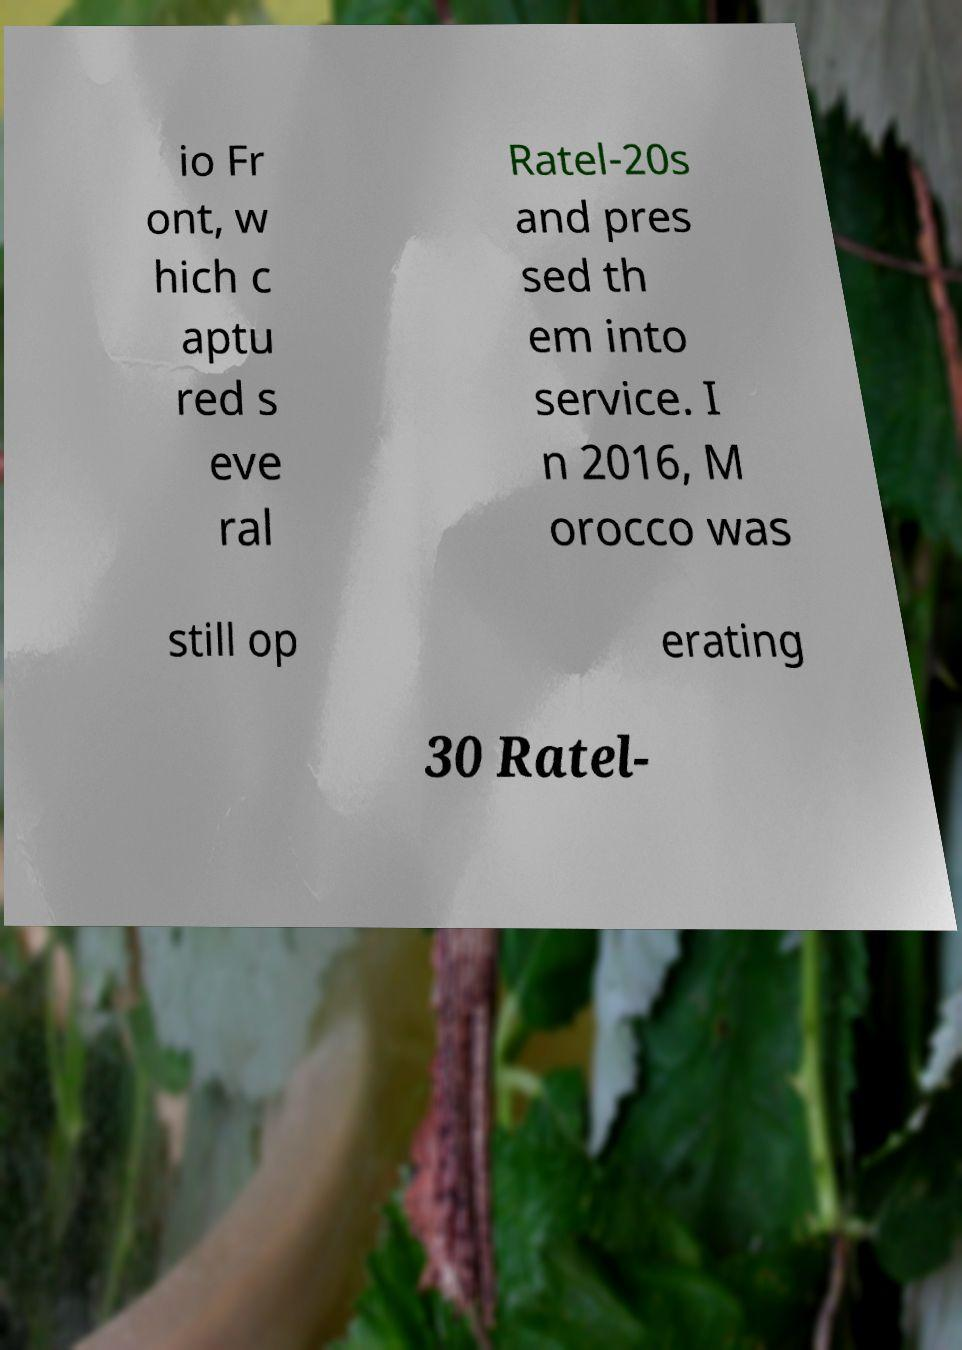What messages or text are displayed in this image? I need them in a readable, typed format. io Fr ont, w hich c aptu red s eve ral Ratel-20s and pres sed th em into service. I n 2016, M orocco was still op erating 30 Ratel- 